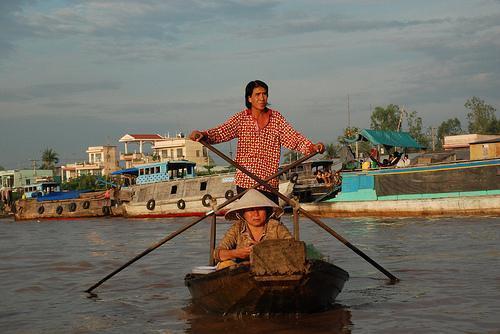How many people are on the boat?
Give a very brief answer. 2. How many oars does the rower use?
Give a very brief answer. 2. 